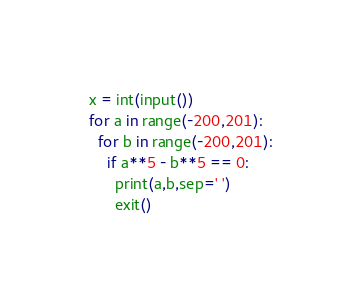Convert code to text. <code><loc_0><loc_0><loc_500><loc_500><_Python_>x = int(input())
for a in range(-200,201):
  for b in range(-200,201):
    if a**5 - b**5 == 0:
      print(a,b,sep=' ')
      exit()</code> 